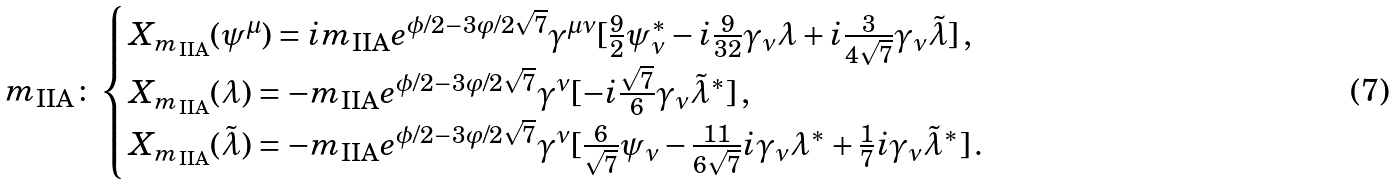Convert formula to latex. <formula><loc_0><loc_0><loc_500><loc_500>m _ { \text {IIA} } \colon & \begin{cases} X _ { m _ { \text {IIA} } } ( \psi ^ { \mu } ) = i m _ { \text {IIA} } e ^ { \phi / 2 - 3 \varphi / 2 \sqrt { 7 } } \gamma ^ { \mu \nu } [ \frac { 9 } { 2 } \psi _ { \nu } ^ { * } - i \frac { 9 } { 3 2 } \gamma _ { \nu } \lambda + i \frac { 3 } { 4 \sqrt { 7 } } \gamma _ { \nu } \tilde { \lambda } ] \, , \\ X _ { m _ { \text {IIA} } } ( \lambda ) = - m _ { \text {IIA} } e ^ { \phi / 2 - 3 \varphi / 2 \sqrt { 7 } } \gamma ^ { \nu } [ - i \frac { \sqrt { 7 } } { 6 } \gamma _ { \nu } \tilde { \lambda } ^ { * } ] \, , \\ X _ { m _ { \text {IIA} } } ( \tilde { \lambda } ) = - m _ { \text {IIA} } e ^ { \phi / 2 - 3 \varphi / 2 \sqrt { 7 } } \gamma ^ { \nu } [ \frac { 6 } { \sqrt { 7 } } \psi _ { \nu } - \frac { 1 1 } { 6 \sqrt { 7 } } i \gamma _ { \nu } \lambda ^ { * } + \frac { 1 } { 7 } i \gamma _ { \nu } \tilde { \lambda } ^ { * } ] \, . \end{cases}</formula> 